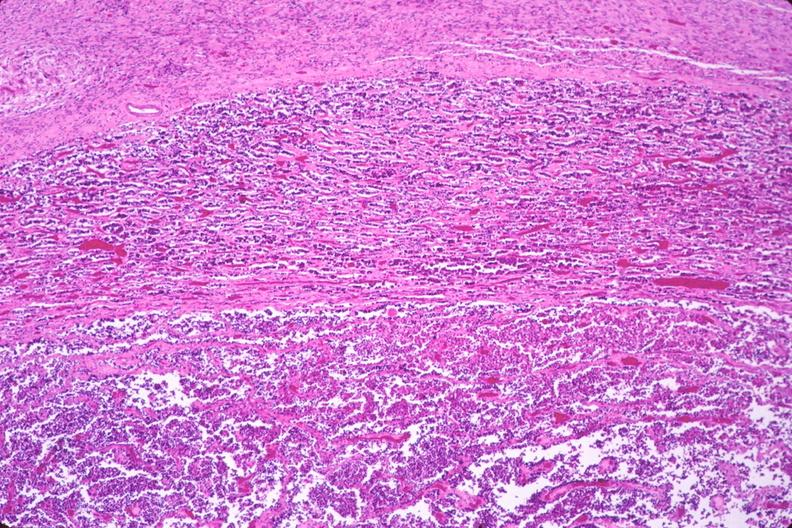s endocrine present?
Answer the question using a single word or phrase. Yes 